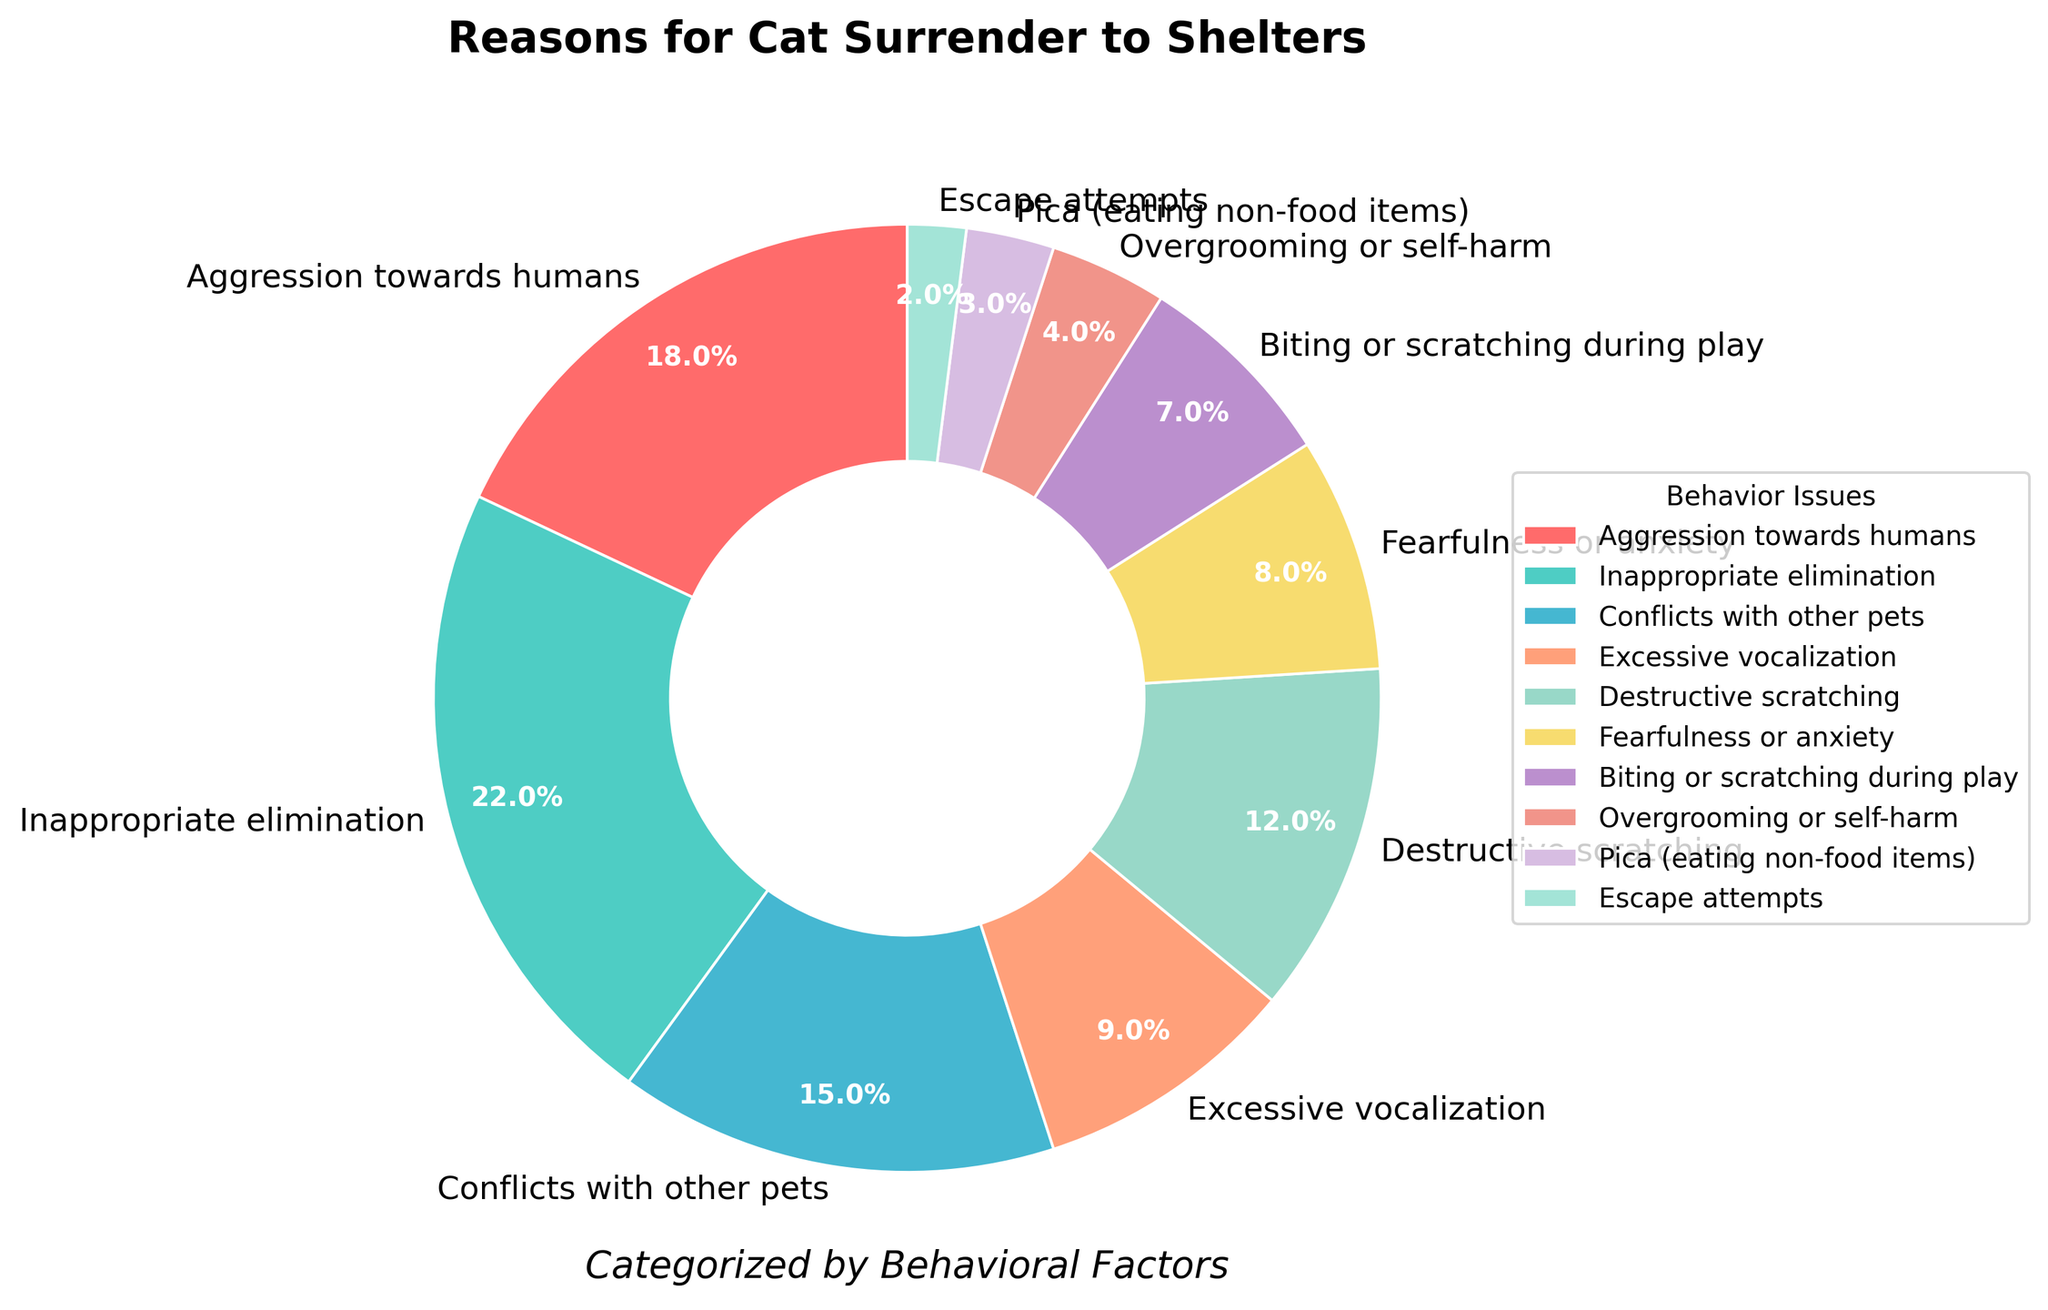Which behavior issue has the highest percentage? The largest section of the pie chart corresponds to inappropriate elimination, which has the highest percentage.
Answer: Inappropriate elimination What is the combined percentage of cats surrendered due to aggression towards humans and conflicts with other pets? Add the percentages for the two issues: 18% (aggression towards humans) + 15% (conflicts with other pets) = 33%.
Answer: 33% Which behavior issue has a lower percentage: excessive vocalization or destructive scratching? Compare the two sections of the pie chart. Excessive vocalization has 9% and destructive scratching has 12%. So, excessive vocalization has the lower percentage.
Answer: Excessive vocalization How much higher is the percentage of inappropriate elimination compared to fearfulness or anxiety? Subtract the smaller percentage from the larger one: 22% (inappropriate elimination) - 8% (fearfulness or anxiety) = 14%.
Answer: 14% What is the median percentage of all the behavior issues listed? First, list the percentages in ascending order: 2, 3, 4, 7, 8, 9, 12, 15, 18, 22. Since there are 10 data points, the median is the average of the 5th and 6th values: (8 + 9) / 2 = 8.5.
Answer: 8.5 Identify the behavior issue represented by the teal color in the pie chart. The pie chart includes corresponding colors in the legend, and the teal color matches conflicts with other pets.
Answer: Conflicts with other pets Which behavior has the smallest representation in the pie chart? The pie chart section with the smallest size corresponds to escape attempts at 2%.
Answer: Escape attempts Are there more cats surrendered due to biting or scratching during play compared to overgrooming or self-harm? Compare the two percentages. Biting or scratching during play is 7% and overgrooming or self-harm is 4%, so yes, more cats are surrendered due to biting or scratching during play.
Answer: Yes What is the difference in the percentage between cats surrendered for inappropriate elimination and those for destructive scratching? Subtract the percentage of destructive scratching from inappropriate elimination: 22% - 12% = 10%.
Answer: 10% Which behavioral issue is represented by the pink color in the chart? Referring to the legend, the pink color corresponds to excessive vocalization.
Answer: Excessive vocalization 